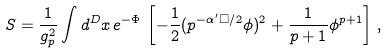<formula> <loc_0><loc_0><loc_500><loc_500>S = \frac { 1 } { g _ { p } ^ { 2 } } \int d ^ { D } x \, e ^ { - \Phi } \, \left [ - \frac { 1 } { 2 } ( p ^ { - \alpha ^ { \prime } \Box / 2 } \phi ) ^ { 2 } + \frac { 1 } { p + 1 } \phi ^ { p + 1 } \right ] \, ,</formula> 